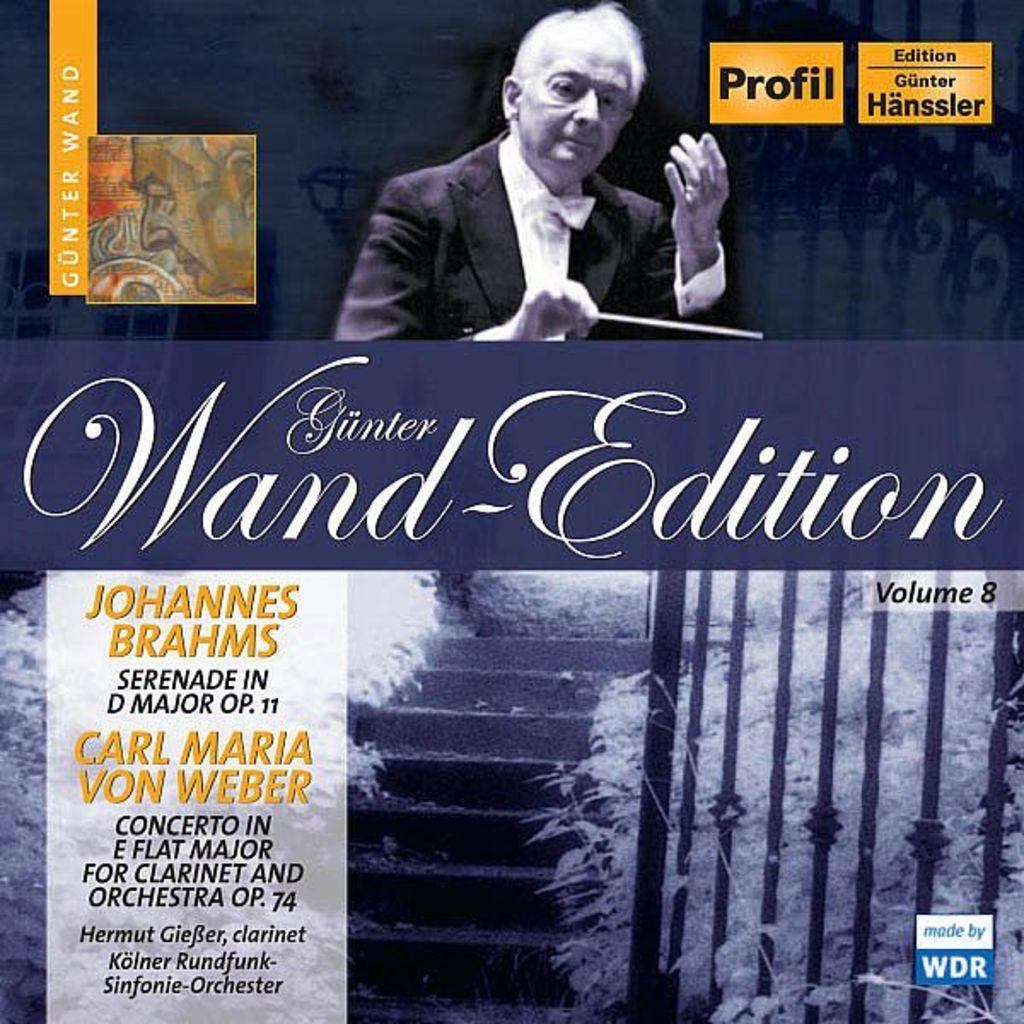<image>
Summarize the visual content of the image. The cover a classical music album by Johannes Brahms. 